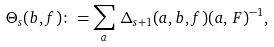<formula> <loc_0><loc_0><loc_500><loc_500>\Theta _ { s } ( { b } , { f } ) \colon = \sum _ { a } \, \Delta _ { s + 1 } ( { a } , { b } , { f } ) ( { a } , \, F ) ^ { - 1 } ,</formula> 